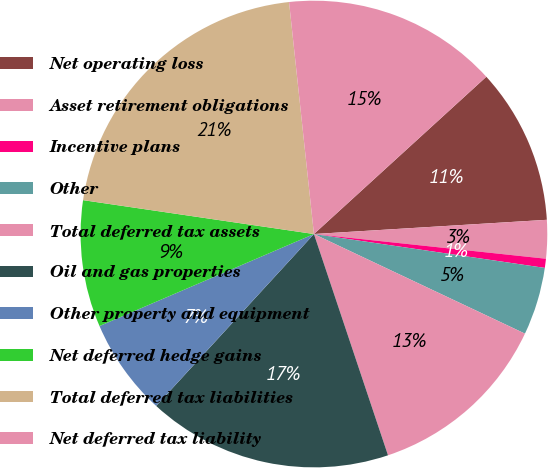<chart> <loc_0><loc_0><loc_500><loc_500><pie_chart><fcel>Net operating loss<fcel>Asset retirement obligations<fcel>Incentive plans<fcel>Other<fcel>Total deferred tax assets<fcel>Oil and gas properties<fcel>Other property and equipment<fcel>Net deferred hedge gains<fcel>Total deferred tax liabilities<fcel>Net deferred tax liability<nl><fcel>10.8%<fcel>2.66%<fcel>0.63%<fcel>4.7%<fcel>12.84%<fcel>16.96%<fcel>6.73%<fcel>8.77%<fcel>20.98%<fcel>14.93%<nl></chart> 